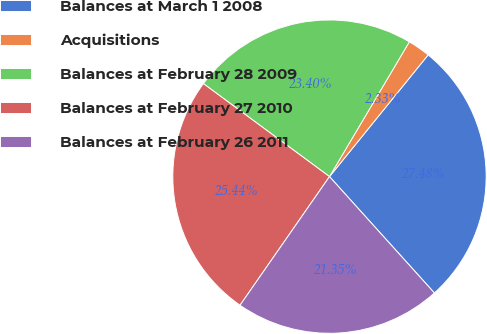Convert chart to OTSL. <chart><loc_0><loc_0><loc_500><loc_500><pie_chart><fcel>Balances at March 1 2008<fcel>Acquisitions<fcel>Balances at February 28 2009<fcel>Balances at February 27 2010<fcel>Balances at February 26 2011<nl><fcel>27.48%<fcel>2.33%<fcel>23.4%<fcel>25.44%<fcel>21.35%<nl></chart> 